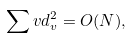Convert formula to latex. <formula><loc_0><loc_0><loc_500><loc_500>\sum v d _ { v } ^ { 2 } = O ( N ) ,</formula> 